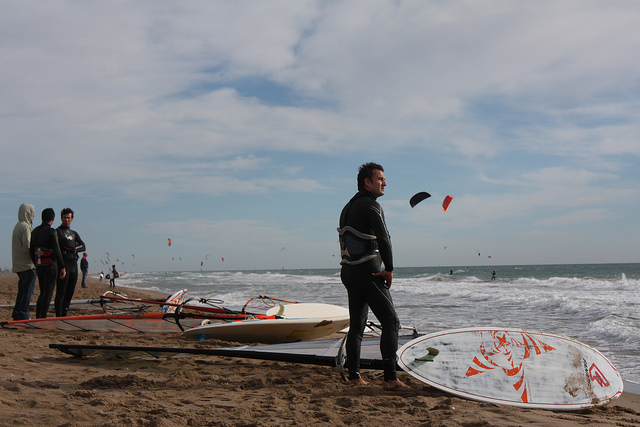<image>What brand of shoes is the skateboarder wearing? It is unknown what brand of shoes the skateboarder is wearing. However, it can be nike, dc or billabong. Which man is controlling the kite? It's ambiguous which man is controlling the kite. It could be the man in the front or in the back. It's also possible that there is no kite at all. Which man is controlling the kite? It is ambiguous which man is controlling the kite. What brand of shoes is the skateboarder wearing? I am not sure what brand of shoes the skateboarder is wearing. It can be seen 'tennis shoes', 'dc', 'billabong', 'cabela's' or 'nike'. 